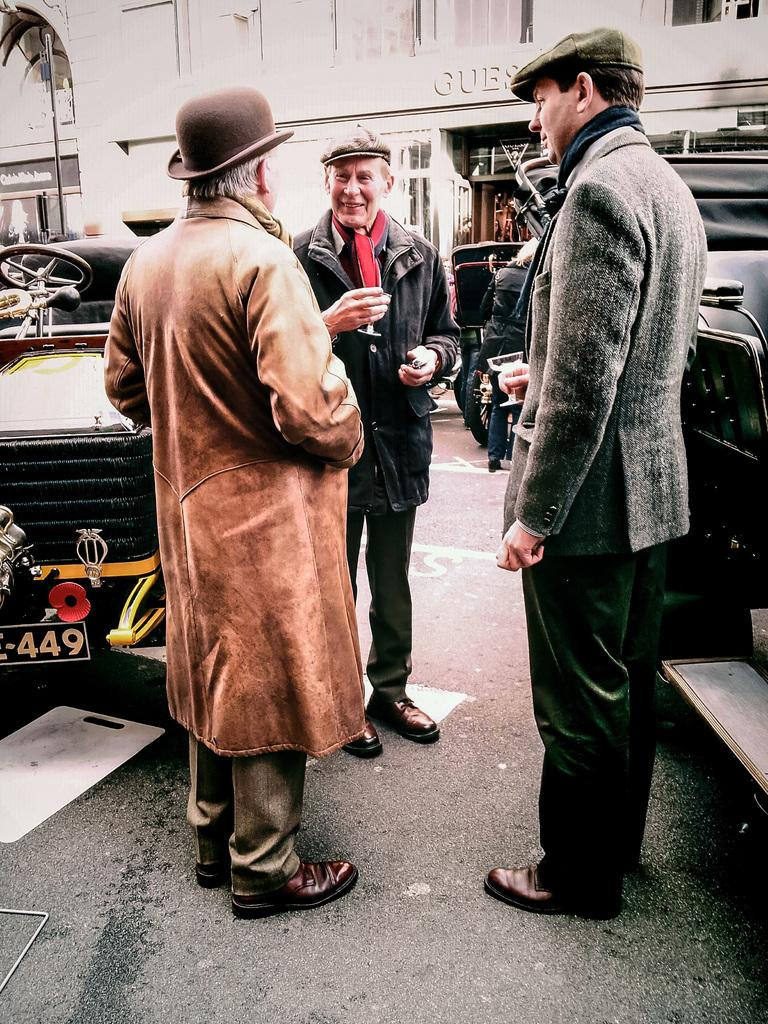Who or what can be seen in the image? There are people in the image. What else is present in the image besides people? There are vehicles and buildings in the image. How many eggs are visible in the image? There are no eggs present in the image. What type of good-bye gesture can be seen in the image? There is no good-bye gesture depicted in the image. 